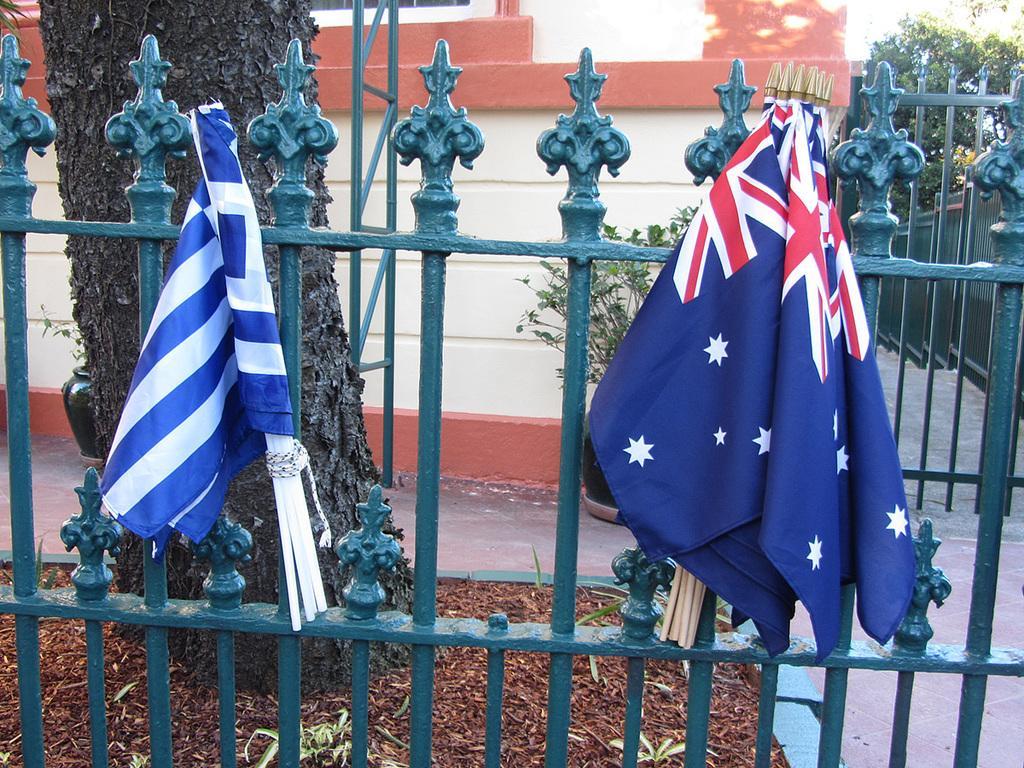How would you summarize this image in a sentence or two? In this picture there are two flags tightened to a iron fence which is in green color behind it and there is a tree trunk and a building in the background. 